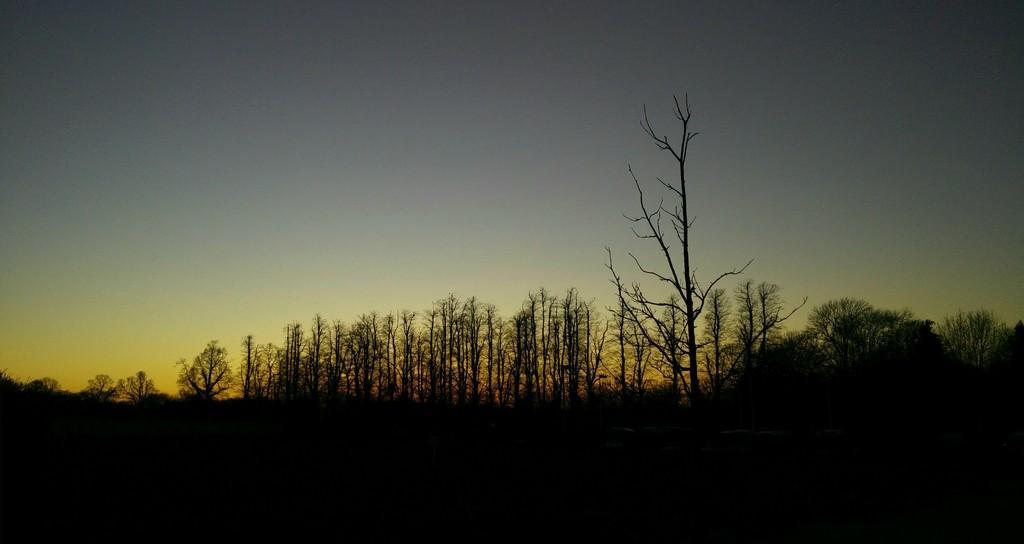How would you summarize this image in a sentence or two? In this picture I can see trees and I can see sky. 